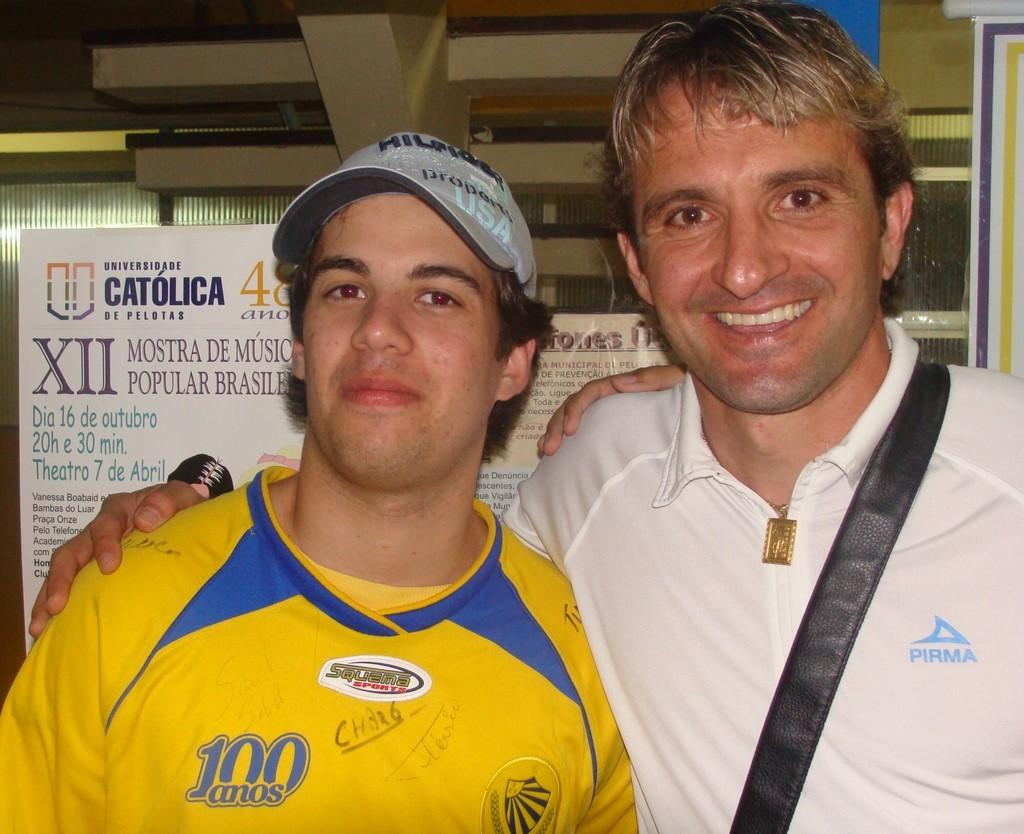Provide a one-sentence caption for the provided image. A logo on a yellow shirt represents 100 years. 